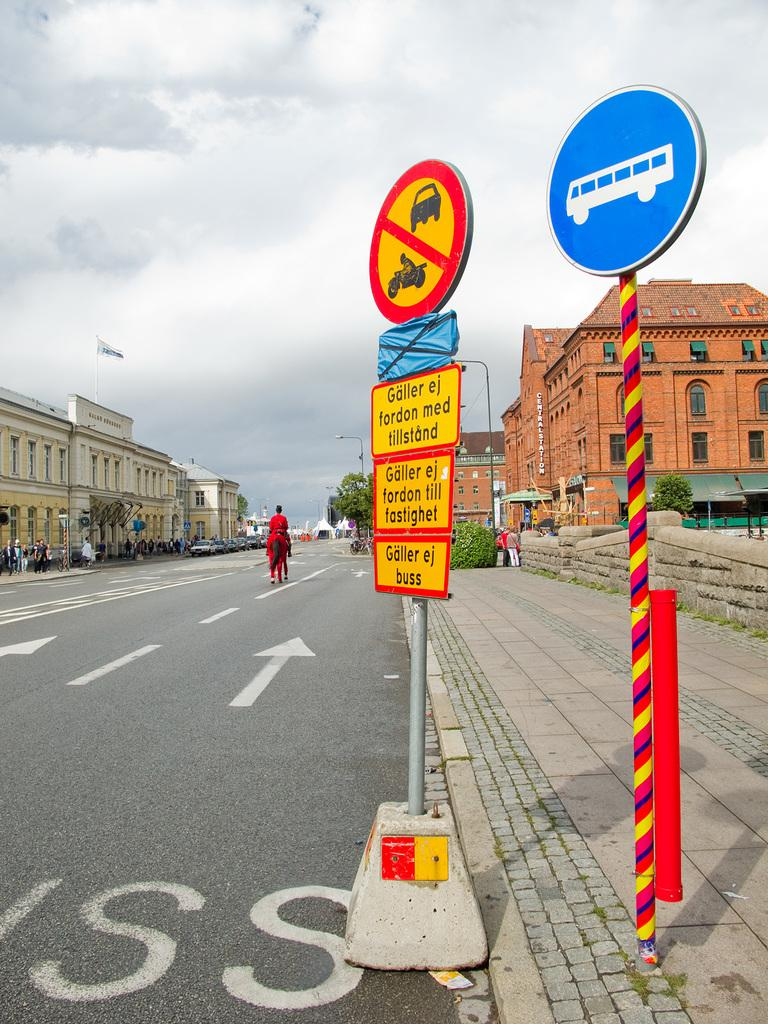<image>
Offer a succinct explanation of the picture presented. Street signs on the edge of a road in a non english language read " Galler ej fordon med tillstand". 